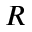<formula> <loc_0><loc_0><loc_500><loc_500>R</formula> 